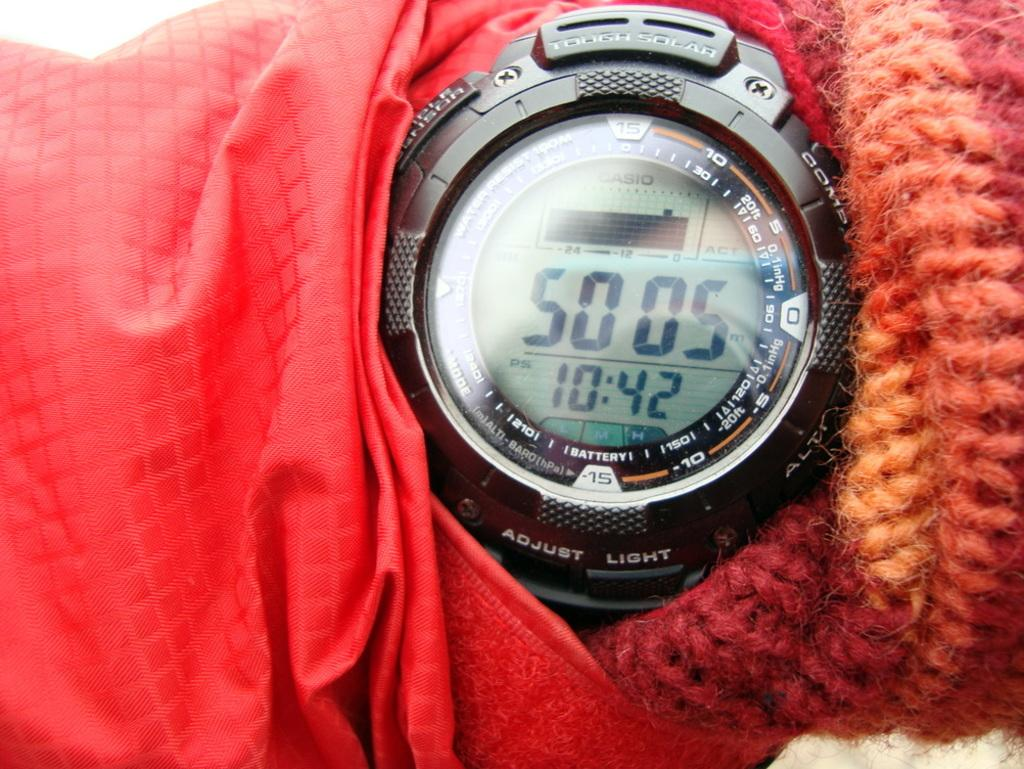<image>
Provide a brief description of the given image. A Casio watch show that the time is now 10:42. 